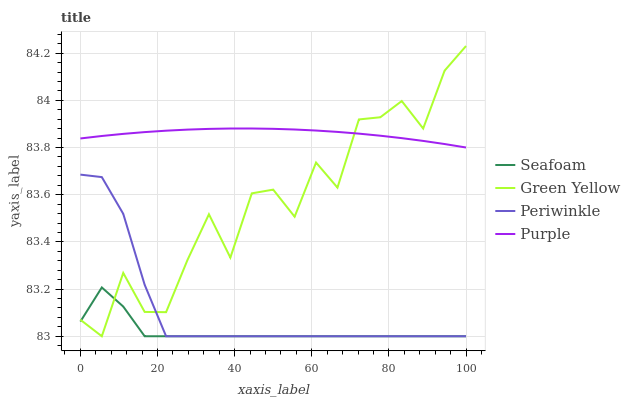Does Seafoam have the minimum area under the curve?
Answer yes or no. Yes. Does Purple have the maximum area under the curve?
Answer yes or no. Yes. Does Green Yellow have the minimum area under the curve?
Answer yes or no. No. Does Green Yellow have the maximum area under the curve?
Answer yes or no. No. Is Purple the smoothest?
Answer yes or no. Yes. Is Green Yellow the roughest?
Answer yes or no. Yes. Is Periwinkle the smoothest?
Answer yes or no. No. Is Periwinkle the roughest?
Answer yes or no. No. Does Green Yellow have the lowest value?
Answer yes or no. Yes. Does Green Yellow have the highest value?
Answer yes or no. Yes. Does Periwinkle have the highest value?
Answer yes or no. No. Is Seafoam less than Purple?
Answer yes or no. Yes. Is Purple greater than Periwinkle?
Answer yes or no. Yes. Does Green Yellow intersect Periwinkle?
Answer yes or no. Yes. Is Green Yellow less than Periwinkle?
Answer yes or no. No. Is Green Yellow greater than Periwinkle?
Answer yes or no. No. Does Seafoam intersect Purple?
Answer yes or no. No. 